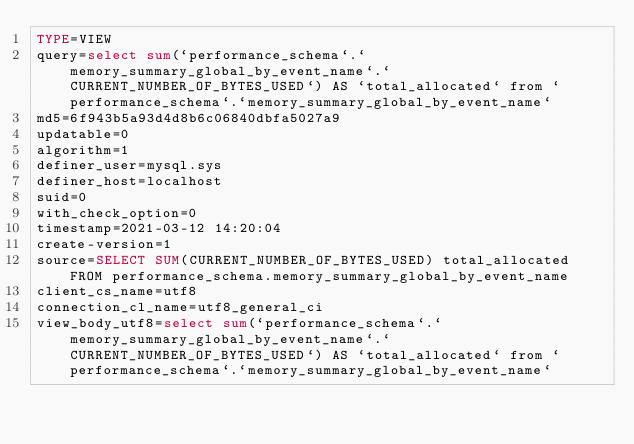Convert code to text. <code><loc_0><loc_0><loc_500><loc_500><_VisualBasic_>TYPE=VIEW
query=select sum(`performance_schema`.`memory_summary_global_by_event_name`.`CURRENT_NUMBER_OF_BYTES_USED`) AS `total_allocated` from `performance_schema`.`memory_summary_global_by_event_name`
md5=6f943b5a93d4d8b6c06840dbfa5027a9
updatable=0
algorithm=1
definer_user=mysql.sys
definer_host=localhost
suid=0
with_check_option=0
timestamp=2021-03-12 14:20:04
create-version=1
source=SELECT SUM(CURRENT_NUMBER_OF_BYTES_USED) total_allocated FROM performance_schema.memory_summary_global_by_event_name
client_cs_name=utf8
connection_cl_name=utf8_general_ci
view_body_utf8=select sum(`performance_schema`.`memory_summary_global_by_event_name`.`CURRENT_NUMBER_OF_BYTES_USED`) AS `total_allocated` from `performance_schema`.`memory_summary_global_by_event_name`
</code> 